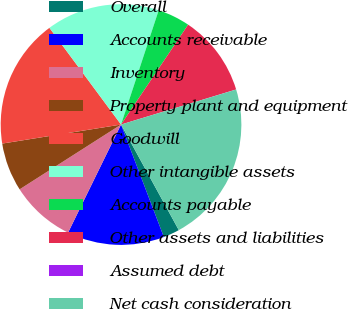Convert chart to OTSL. <chart><loc_0><loc_0><loc_500><loc_500><pie_chart><fcel>Overall<fcel>Accounts receivable<fcel>Inventory<fcel>Property plant and equipment<fcel>Goodwill<fcel>Other intangible assets<fcel>Accounts payable<fcel>Other assets and liabilities<fcel>Assumed debt<fcel>Net cash consideration<nl><fcel>2.18%<fcel>13.04%<fcel>8.7%<fcel>6.52%<fcel>17.38%<fcel>15.21%<fcel>4.35%<fcel>10.87%<fcel>0.01%<fcel>21.73%<nl></chart> 